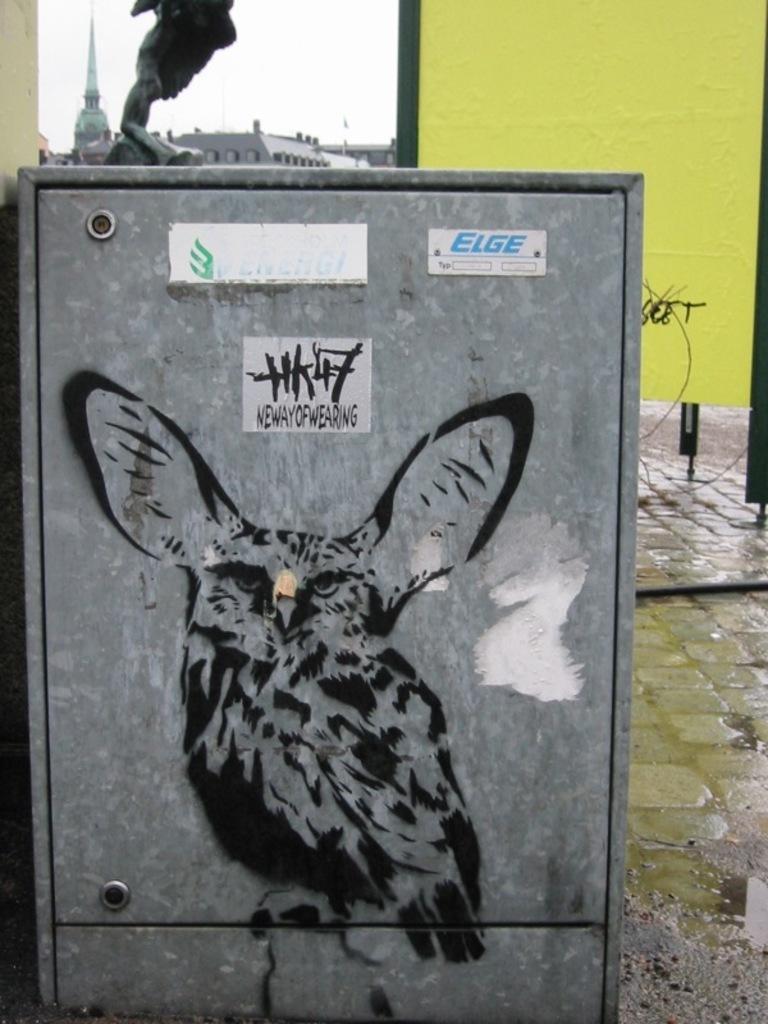Can you describe this image briefly? In this picture we can see a metal box, on this metal box we can see a painting of a bird, posters on it and in the background we can see the ground, wall and some objects. 